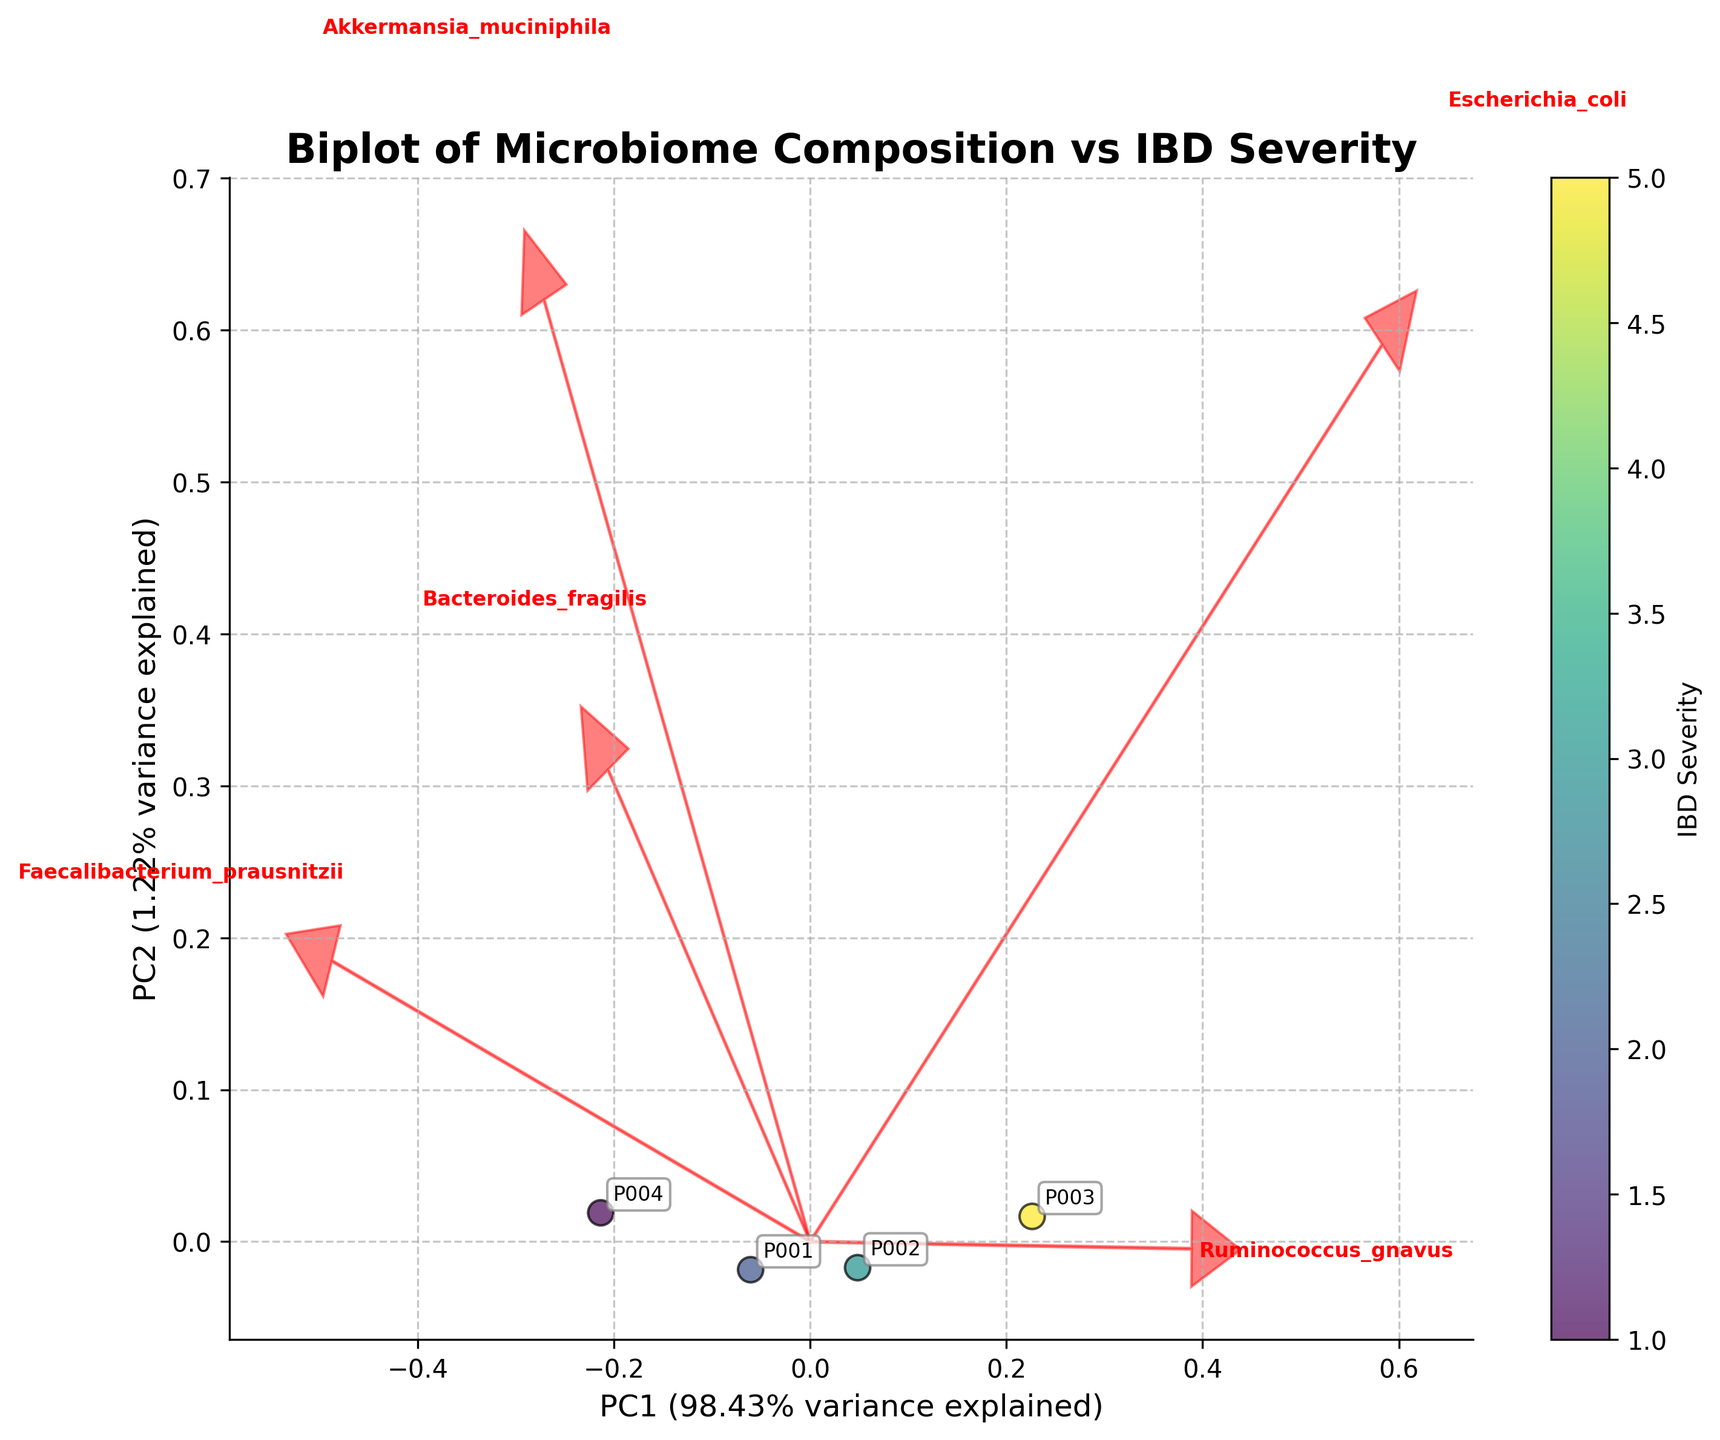1. What is the title of the figure? The title of the figure is usually displayed at the top. In this figure, it reads 'Biplot of Microbiome Composition vs IBD Severity'.
Answer: Biplot of Microbiome Composition vs IBD Severity 2. How many patients are represented in the figure? Each patient is represented by a data point labeled with their ID. Counting these points gives the total number of patients.
Answer: 4 3. What do the colors of the points represent? The color gradient shown in the colorbar next to the plot indicates the level of IBD Severity for each data point.
Answer: IBD Severity 4. Which species has the largest positive loading on PC1? The arrows originating from the origin point towards the direction of species loadings. The species with the arrow extending farthest in the positive direction along PC1 has the largest positive loading.
Answer: Faecalibacterium_prausnitzii 5. Which axis explains a higher percentage of the variance in the data? The axis labels show the percentage of variance explained by each principal component. Comparing these percentages tells us which explains more variance. PC1 explains 65.85% whereas PC2 explains 24.33%.
Answer: PC1 6. What is the approximate IBD Severity of the patient with the highest PC1 value? The position of points on the plot corresponds to their PC1 values. The highest PC1 value corresponds to the rightmost point. The color of this point, matched to the colorbar, indicates IBD Severity.
Answer: 1 7. Which species appears to have the strongest negative correlation with PC1? The species with the arrow extending farthest in the negative direction along PC1 has the strongest negative correlation.
Answer: Escherichia_coli 8. Which two species vectors are closest to each other in direction? To find the closest vectors, look for arrows that are most parallel to each other.
Answer: Faecalibacterium_prausnitzii and Bacteroides_fragilis 9. How many species vectors are shown in the plot? Each species is represented by an arrow. Counting these arrows gives the number of species vectors.
Answer: 5 10. Which patient is closest to the vector of Ruminococcus gnavus? Find the data point nearest to the direction of the arrow representing Ruminococcus_gnavus. Annotations and the location of the arrows help determine the closest patient.
Answer: P003 